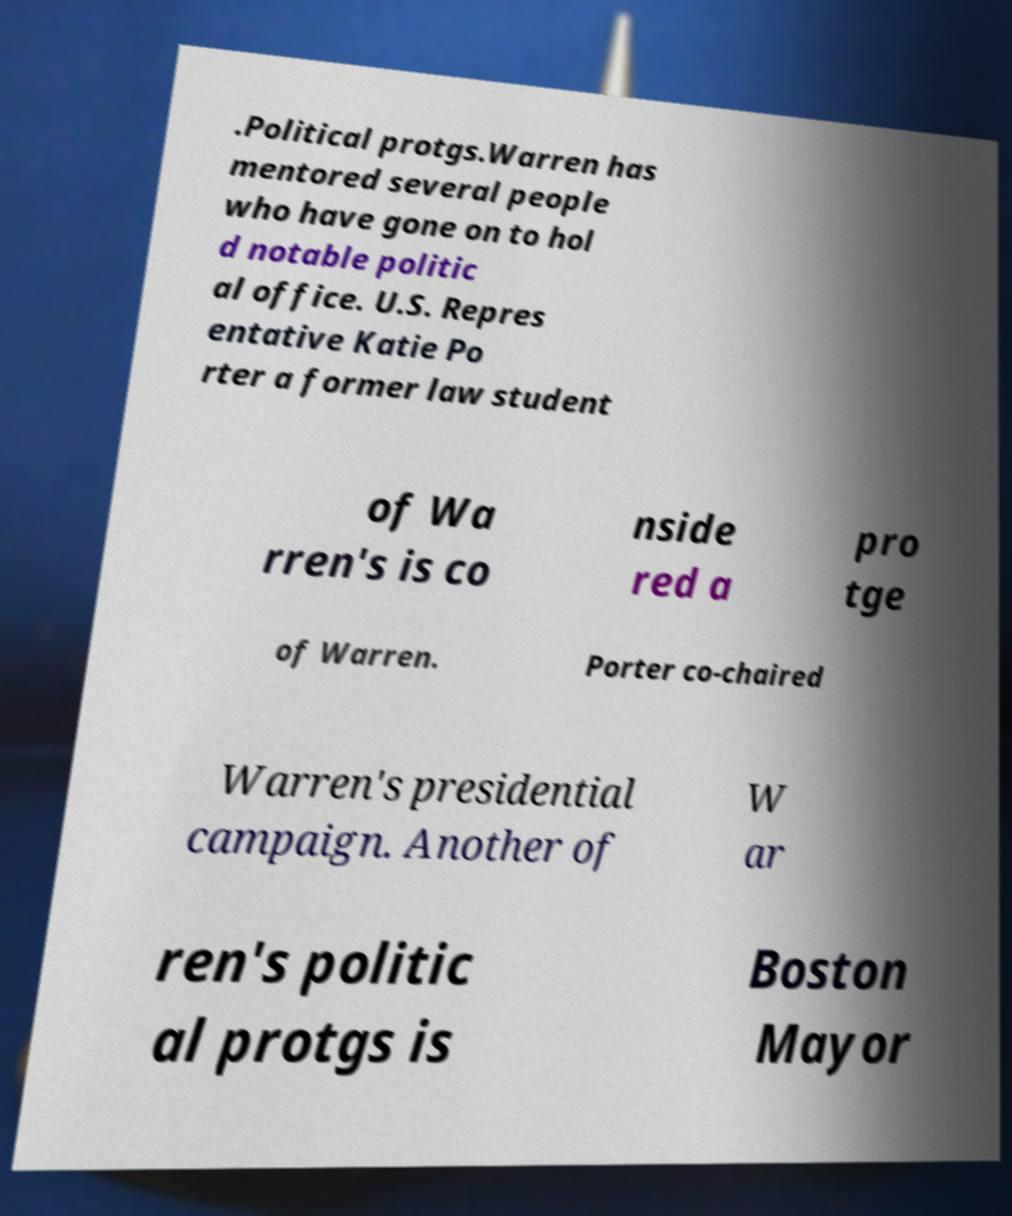There's text embedded in this image that I need extracted. Can you transcribe it verbatim? .Political protgs.Warren has mentored several people who have gone on to hol d notable politic al office. U.S. Repres entative Katie Po rter a former law student of Wa rren's is co nside red a pro tge of Warren. Porter co-chaired Warren's presidential campaign. Another of W ar ren's politic al protgs is Boston Mayor 